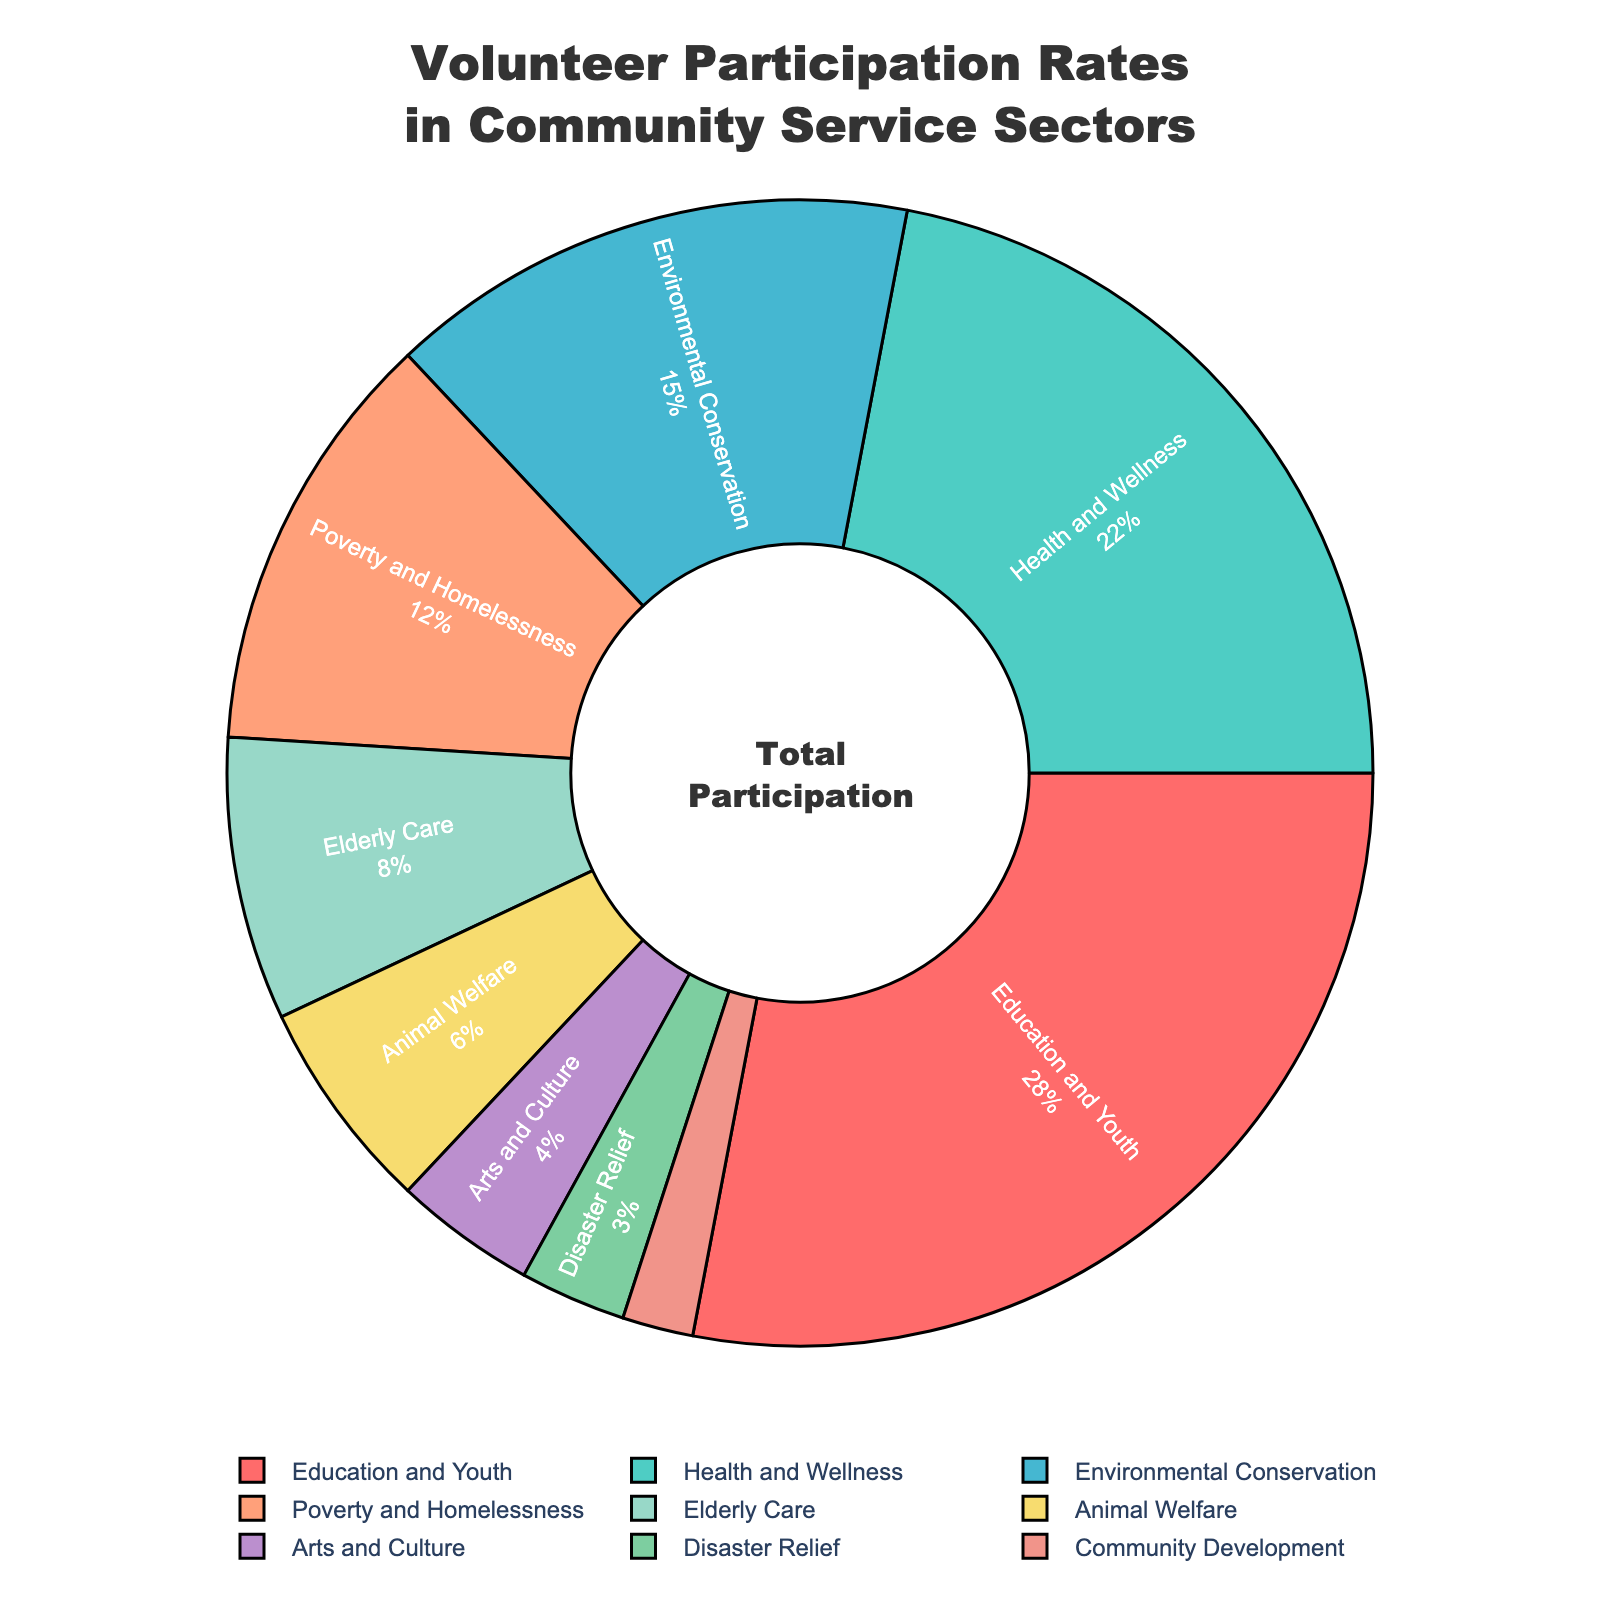What sector has the highest participation rate? The figure shows that the 'Education and Youth' sector has the highest participation rate. This can be observed by the largest segment in the pie chart.
Answer: Education and Youth What's the combined participation rate for 'Health and Wellness' and 'Environmental Conservation'? To find the combined rate, add the participation rates for 'Health and Wellness' (22) and 'Environmental Conservation' (15). 22 + 15 = 37
Answer: 37 Which sector has the smallest participation rate? The pie chart shows that 'Community Development' has the smallest segment, indicating the lowest participation rate.
Answer: Community Development Which two sectors together account for more than 50% of the participation rate? By looking at the chart, we see 'Education and Youth' (28%) and 'Health and Wellness' (22%) together account for 28 + 22 = 50, which is exactly at 50% but still not more than 50%. So the answer should add another sector. Adding 'Environmental Conservation' (15%) makes it more, i.e., 28 + 22 + 15 = 65%.
Answer: Education and Youth, Health and Wellness, and Environmental Conservation What is the participation rate of 'Poverty and Homelessness' compared to 'Animal Welfare'? 'Poverty and Homelessness' has a rate of 12%, while 'Animal Welfare' has a rate of 6%. By comparison, 12% is greater than 6%.
Answer: Poverty and Homelessness is greater How much higher is the participation rate in 'Health and Wellness' than in 'Arts and Culture'? Subtract the participation rate of 'Arts and Culture' (4%) from 'Health and Wellness' (22%). 22 - 4 = 18
Answer: 18 What percentage of total participation does the 'Elderly Care' sector represent? The chart indicates that 'Elderly Care' accounts for 8% of total participation, as shown by the segment's label.
Answer: 8% What is the sum of the participation rates for sectors below 10%? The sectors below 10% are 'Elderly Care' (8%), 'Animal Welfare' (6%), 'Arts and Culture' (4%), 'Disaster Relief' (3%), and 'Community Development' (2%). Summing these gives 8 + 6 + 4 + 3 + 2 = 23
Answer: 23 Which color represents the 'Environmental Conservation' sector? The pie segment labeled 'Environmental Conservation' is shaded in a greenish color.
Answer: Greenish If another sector was added and it had twice the participation rate of 'Disaster Relief', what would be its participation rate? 'Disaster Relief' has a participation rate of 3%. Twice this rate would be 3% * 2 = 6%.
Answer: 6% 